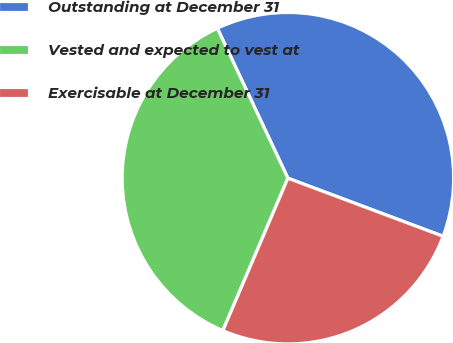Convert chart to OTSL. <chart><loc_0><loc_0><loc_500><loc_500><pie_chart><fcel>Outstanding at December 31<fcel>Vested and expected to vest at<fcel>Exercisable at December 31<nl><fcel>37.7%<fcel>36.58%<fcel>25.72%<nl></chart> 